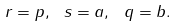Convert formula to latex. <formula><loc_0><loc_0><loc_500><loc_500>r = p , \ s = a , \ q = b .</formula> 